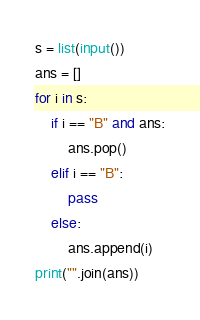Convert code to text. <code><loc_0><loc_0><loc_500><loc_500><_Python_>s = list(input())
ans = []
for i in s:
    if i == "B" and ans:
        ans.pop()
    elif i == "B":
        pass
    else:
        ans.append(i)
print("".join(ans))</code> 